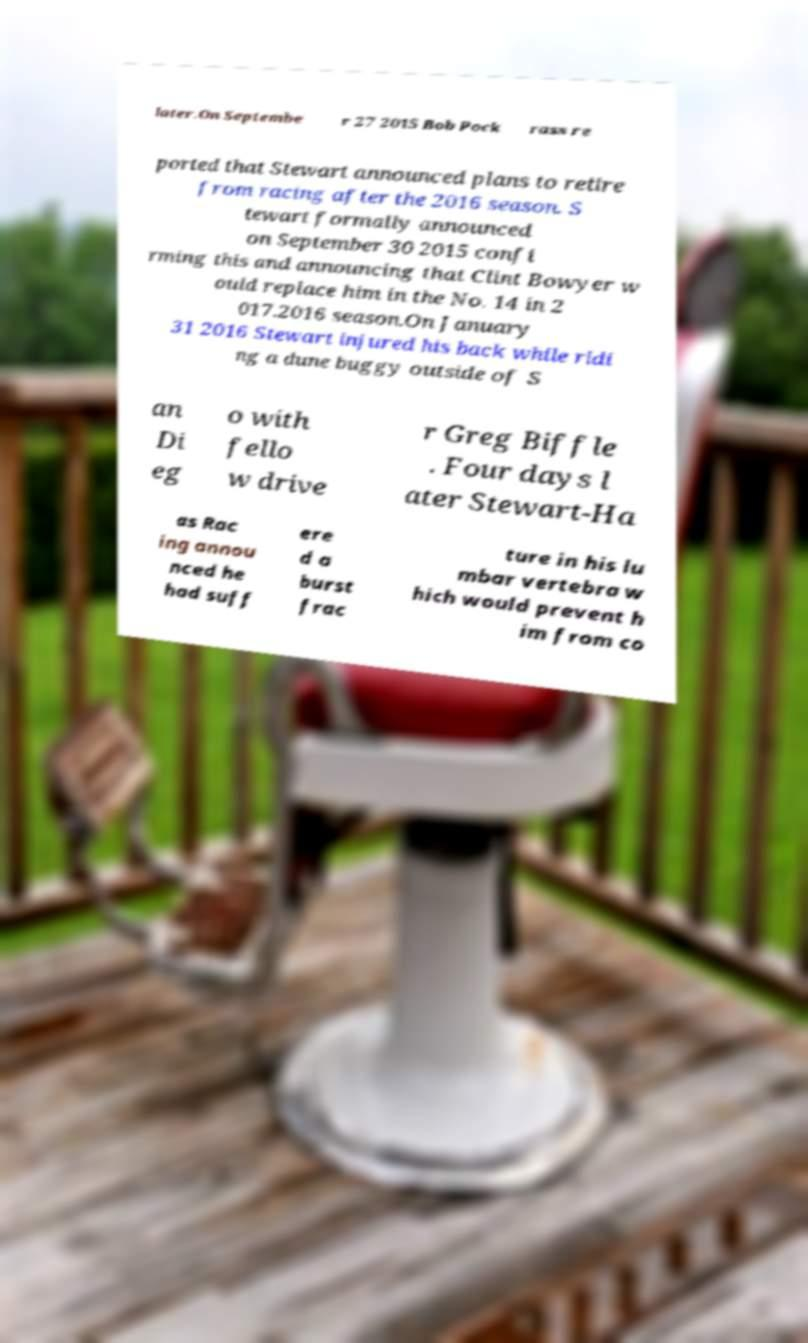I need the written content from this picture converted into text. Can you do that? later.On Septembe r 27 2015 Bob Pock rass re ported that Stewart announced plans to retire from racing after the 2016 season. S tewart formally announced on September 30 2015 confi rming this and announcing that Clint Bowyer w ould replace him in the No. 14 in 2 017.2016 season.On January 31 2016 Stewart injured his back while ridi ng a dune buggy outside of S an Di eg o with fello w drive r Greg Biffle . Four days l ater Stewart-Ha as Rac ing annou nced he had suff ere d a burst frac ture in his lu mbar vertebra w hich would prevent h im from co 